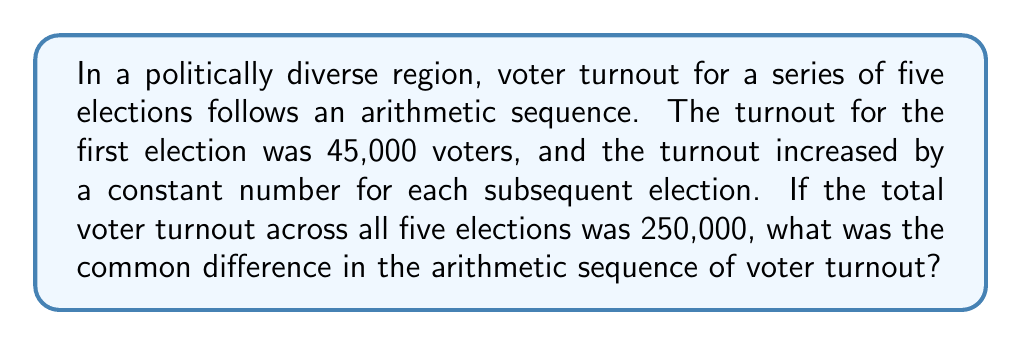Can you solve this math problem? Let's approach this step-by-step:

1) Let $d$ be the common difference in the arithmetic sequence.

2) The arithmetic sequence for the five elections can be represented as:
   $45000, 45000+d, 45000+2d, 45000+3d, 45000+4d$

3) The sum of an arithmetic sequence is given by:
   $S_n = \frac{n}{2}(a_1 + a_n)$
   where $S_n$ is the sum, $n$ is the number of terms, $a_1$ is the first term, and $a_n$ is the last term.

4) In this case:
   $n = 5$
   $a_1 = 45000$
   $a_5 = 45000 + 4d$
   $S_5 = 250000$

5) Plugging these into the formula:
   $250000 = \frac{5}{2}(45000 + (45000 + 4d))$

6) Simplifying:
   $250000 = \frac{5}{2}(90000 + 4d)$
   $250000 = 225000 + 10d$

7) Subtracting 225000 from both sides:
   $25000 = 10d$

8) Dividing both sides by 10:
   $2500 = d$

Therefore, the common difference in the arithmetic sequence is 2500.
Answer: 2500 